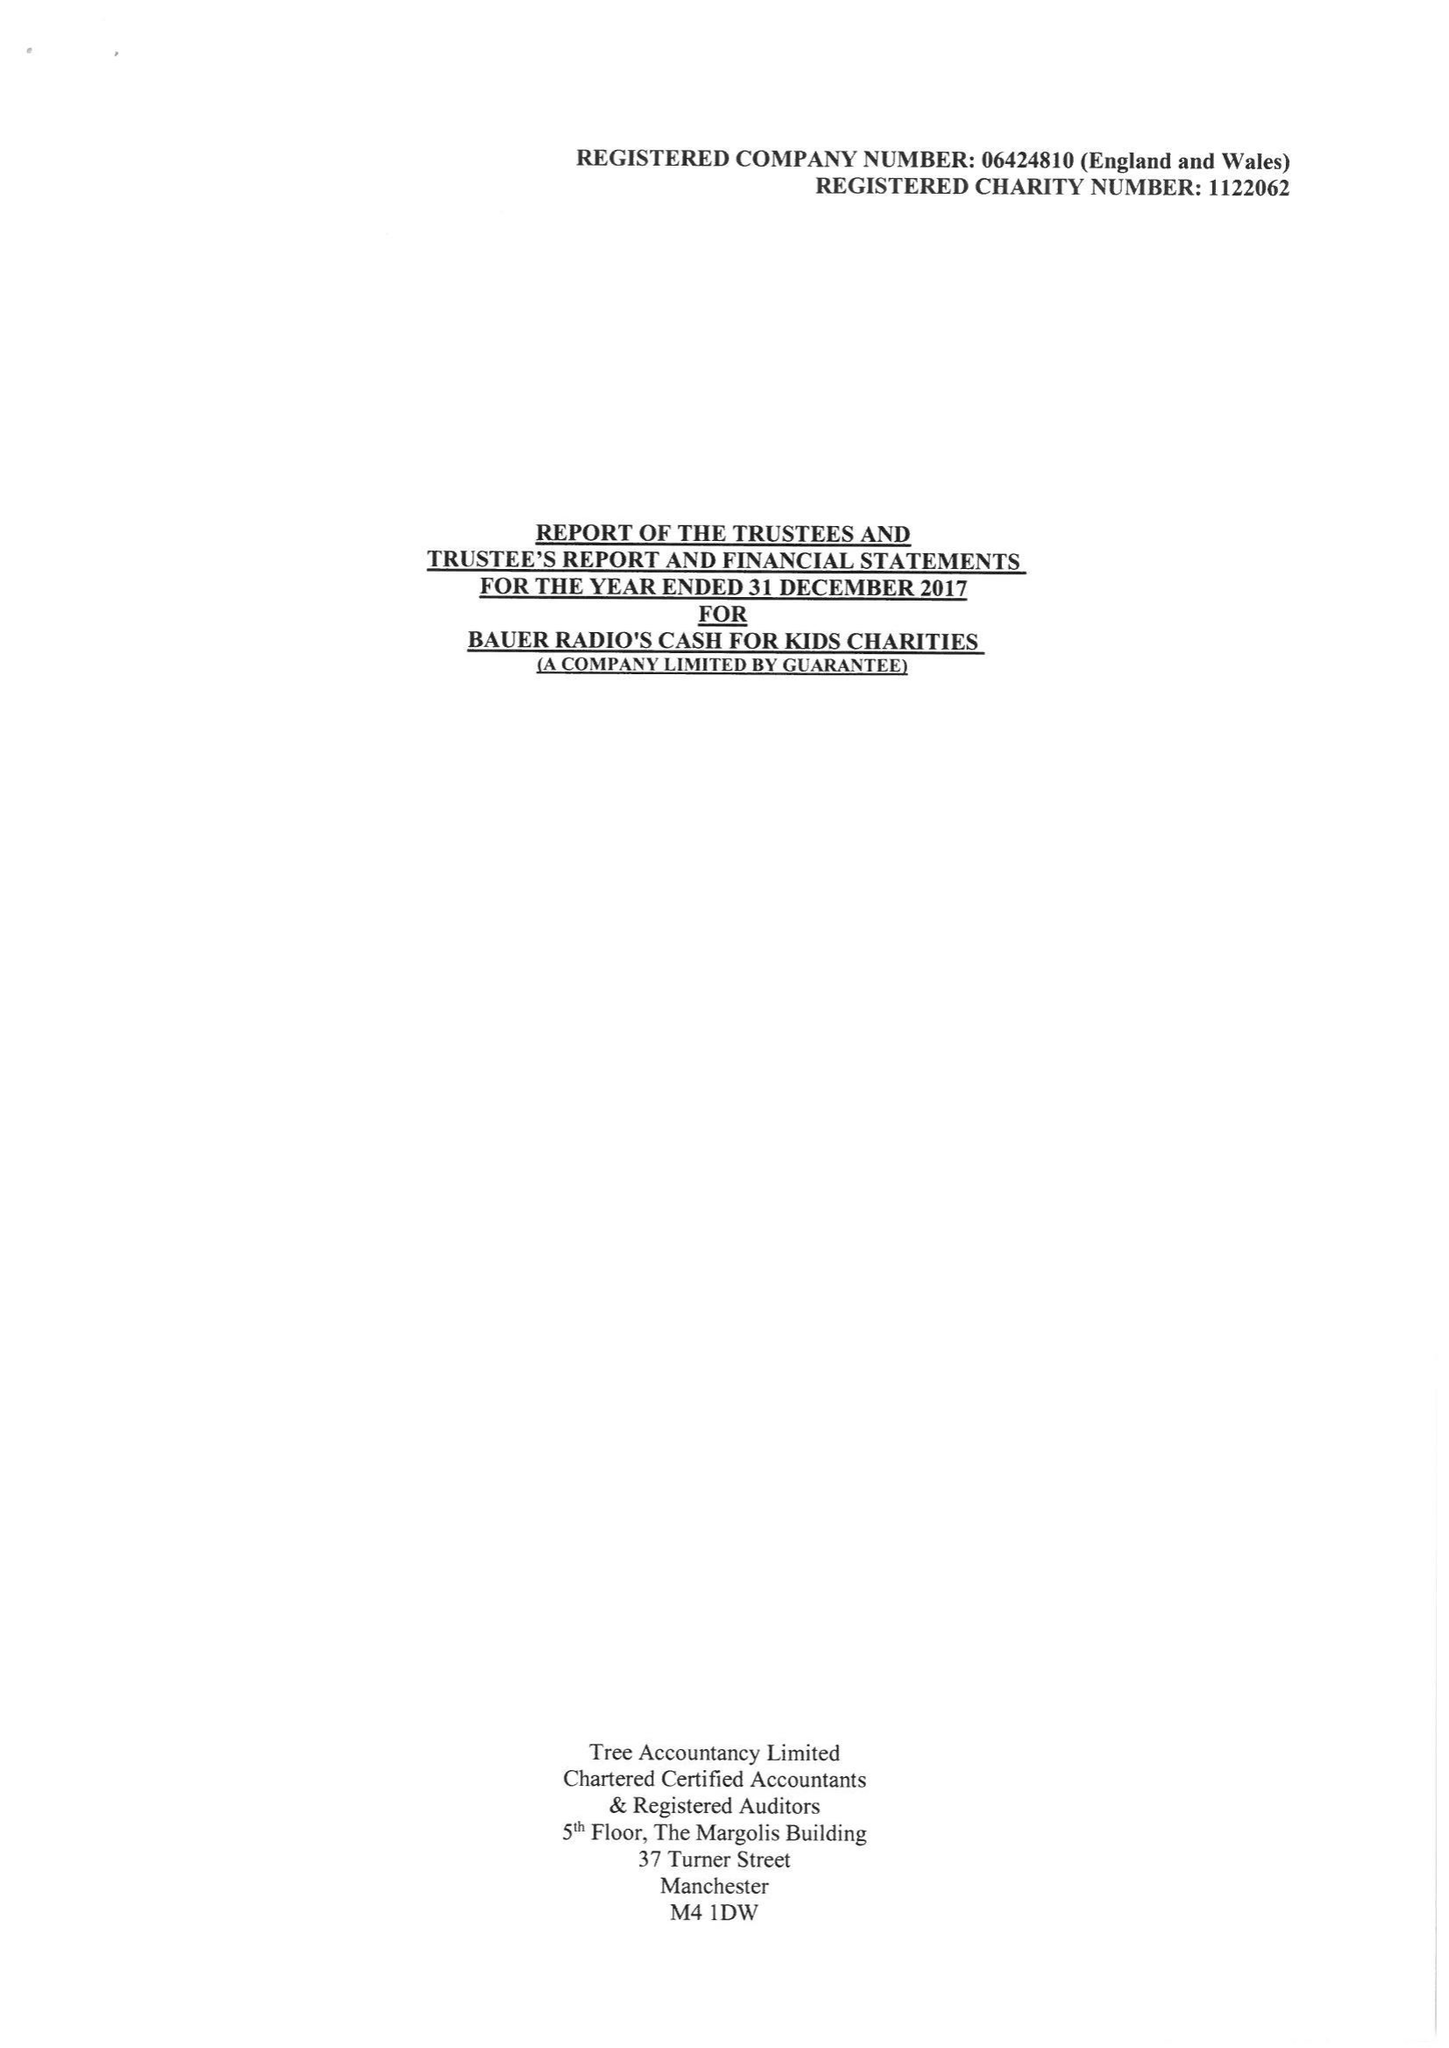What is the value for the charity_name?
Answer the question using a single word or phrase. Bauer Radio's Cash For Kids Charities 